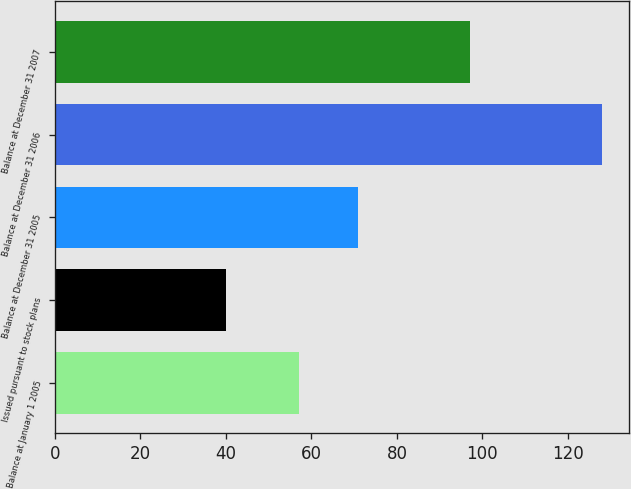Convert chart. <chart><loc_0><loc_0><loc_500><loc_500><bar_chart><fcel>Balance at January 1 2005<fcel>Issued pursuant to stock plans<fcel>Balance at December 31 2005<fcel>Balance at December 31 2006<fcel>Balance at December 31 2007<nl><fcel>57<fcel>40<fcel>71<fcel>128<fcel>97<nl></chart> 